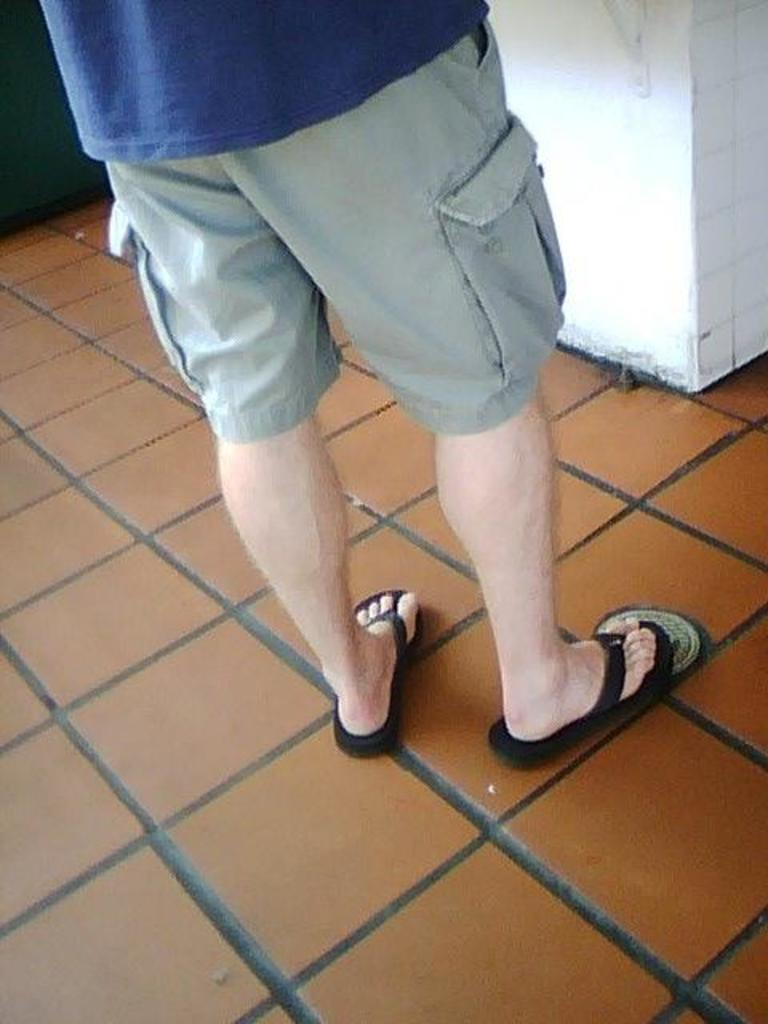What is the main subject of the image? There is a person in the image. What is the person wearing on their upper body? The person is wearing a blue t-shirt. What is the person wearing on their lower body? The person is wearing black shorts. What type of footwear is the person wearing? The person is wearing slippers. Where is the person standing in the image? The person is standing on the floor. What can be seen in the background of the image? There is a wall in the background of the image. Can you tell me how many roses are in the person's hand in the image? There are no roses present in the image; the person is not holding any flowers. What type of advice is the person giving in the image? There is no indication in the image that the person is giving any advice. 